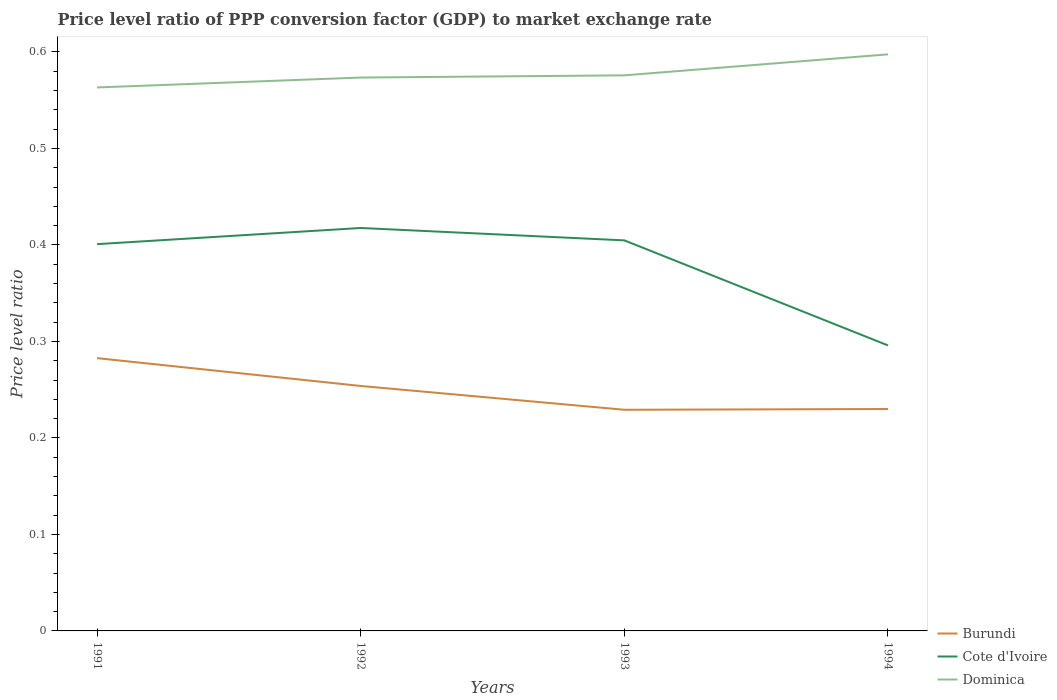Does the line corresponding to Burundi intersect with the line corresponding to Dominica?
Give a very brief answer. No. Is the number of lines equal to the number of legend labels?
Ensure brevity in your answer.  Yes. Across all years, what is the maximum price level ratio in Cote d'Ivoire?
Offer a terse response. 0.3. In which year was the price level ratio in Burundi maximum?
Your answer should be very brief. 1993. What is the total price level ratio in Burundi in the graph?
Your response must be concise. 0.05. What is the difference between the highest and the second highest price level ratio in Burundi?
Your response must be concise. 0.05. What is the difference between the highest and the lowest price level ratio in Dominica?
Give a very brief answer. 1. Is the price level ratio in Cote d'Ivoire strictly greater than the price level ratio in Dominica over the years?
Your response must be concise. Yes. How many lines are there?
Offer a very short reply. 3. What is the difference between two consecutive major ticks on the Y-axis?
Your answer should be very brief. 0.1. How are the legend labels stacked?
Your answer should be compact. Vertical. What is the title of the graph?
Offer a very short reply. Price level ratio of PPP conversion factor (GDP) to market exchange rate. What is the label or title of the X-axis?
Offer a terse response. Years. What is the label or title of the Y-axis?
Provide a short and direct response. Price level ratio. What is the Price level ratio of Burundi in 1991?
Provide a succinct answer. 0.28. What is the Price level ratio of Cote d'Ivoire in 1991?
Ensure brevity in your answer.  0.4. What is the Price level ratio in Dominica in 1991?
Ensure brevity in your answer.  0.56. What is the Price level ratio of Burundi in 1992?
Provide a short and direct response. 0.25. What is the Price level ratio in Cote d'Ivoire in 1992?
Provide a short and direct response. 0.42. What is the Price level ratio in Dominica in 1992?
Provide a short and direct response. 0.57. What is the Price level ratio in Burundi in 1993?
Keep it short and to the point. 0.23. What is the Price level ratio in Cote d'Ivoire in 1993?
Offer a very short reply. 0.4. What is the Price level ratio in Dominica in 1993?
Offer a terse response. 0.58. What is the Price level ratio in Burundi in 1994?
Keep it short and to the point. 0.23. What is the Price level ratio of Cote d'Ivoire in 1994?
Keep it short and to the point. 0.3. What is the Price level ratio in Dominica in 1994?
Your answer should be very brief. 0.6. Across all years, what is the maximum Price level ratio in Burundi?
Your answer should be very brief. 0.28. Across all years, what is the maximum Price level ratio of Cote d'Ivoire?
Make the answer very short. 0.42. Across all years, what is the maximum Price level ratio in Dominica?
Offer a terse response. 0.6. Across all years, what is the minimum Price level ratio in Burundi?
Keep it short and to the point. 0.23. Across all years, what is the minimum Price level ratio in Cote d'Ivoire?
Ensure brevity in your answer.  0.3. Across all years, what is the minimum Price level ratio in Dominica?
Provide a succinct answer. 0.56. What is the total Price level ratio in Burundi in the graph?
Provide a succinct answer. 1. What is the total Price level ratio of Cote d'Ivoire in the graph?
Provide a succinct answer. 1.52. What is the total Price level ratio of Dominica in the graph?
Offer a very short reply. 2.31. What is the difference between the Price level ratio in Burundi in 1991 and that in 1992?
Keep it short and to the point. 0.03. What is the difference between the Price level ratio in Cote d'Ivoire in 1991 and that in 1992?
Give a very brief answer. -0.02. What is the difference between the Price level ratio in Dominica in 1991 and that in 1992?
Offer a terse response. -0.01. What is the difference between the Price level ratio in Burundi in 1991 and that in 1993?
Your answer should be very brief. 0.05. What is the difference between the Price level ratio in Cote d'Ivoire in 1991 and that in 1993?
Keep it short and to the point. -0. What is the difference between the Price level ratio of Dominica in 1991 and that in 1993?
Offer a terse response. -0.01. What is the difference between the Price level ratio of Burundi in 1991 and that in 1994?
Provide a succinct answer. 0.05. What is the difference between the Price level ratio of Cote d'Ivoire in 1991 and that in 1994?
Keep it short and to the point. 0.1. What is the difference between the Price level ratio in Dominica in 1991 and that in 1994?
Offer a terse response. -0.03. What is the difference between the Price level ratio in Burundi in 1992 and that in 1993?
Provide a short and direct response. 0.02. What is the difference between the Price level ratio in Cote d'Ivoire in 1992 and that in 1993?
Ensure brevity in your answer.  0.01. What is the difference between the Price level ratio of Dominica in 1992 and that in 1993?
Your response must be concise. -0. What is the difference between the Price level ratio in Burundi in 1992 and that in 1994?
Offer a terse response. 0.02. What is the difference between the Price level ratio in Cote d'Ivoire in 1992 and that in 1994?
Provide a succinct answer. 0.12. What is the difference between the Price level ratio of Dominica in 1992 and that in 1994?
Provide a succinct answer. -0.02. What is the difference between the Price level ratio of Burundi in 1993 and that in 1994?
Offer a terse response. -0. What is the difference between the Price level ratio in Cote d'Ivoire in 1993 and that in 1994?
Offer a terse response. 0.11. What is the difference between the Price level ratio of Dominica in 1993 and that in 1994?
Ensure brevity in your answer.  -0.02. What is the difference between the Price level ratio in Burundi in 1991 and the Price level ratio in Cote d'Ivoire in 1992?
Your answer should be compact. -0.13. What is the difference between the Price level ratio of Burundi in 1991 and the Price level ratio of Dominica in 1992?
Provide a short and direct response. -0.29. What is the difference between the Price level ratio in Cote d'Ivoire in 1991 and the Price level ratio in Dominica in 1992?
Make the answer very short. -0.17. What is the difference between the Price level ratio of Burundi in 1991 and the Price level ratio of Cote d'Ivoire in 1993?
Your answer should be compact. -0.12. What is the difference between the Price level ratio in Burundi in 1991 and the Price level ratio in Dominica in 1993?
Your answer should be very brief. -0.29. What is the difference between the Price level ratio in Cote d'Ivoire in 1991 and the Price level ratio in Dominica in 1993?
Keep it short and to the point. -0.17. What is the difference between the Price level ratio of Burundi in 1991 and the Price level ratio of Cote d'Ivoire in 1994?
Your response must be concise. -0.01. What is the difference between the Price level ratio of Burundi in 1991 and the Price level ratio of Dominica in 1994?
Keep it short and to the point. -0.31. What is the difference between the Price level ratio in Cote d'Ivoire in 1991 and the Price level ratio in Dominica in 1994?
Provide a succinct answer. -0.2. What is the difference between the Price level ratio of Burundi in 1992 and the Price level ratio of Cote d'Ivoire in 1993?
Provide a short and direct response. -0.15. What is the difference between the Price level ratio in Burundi in 1992 and the Price level ratio in Dominica in 1993?
Provide a succinct answer. -0.32. What is the difference between the Price level ratio in Cote d'Ivoire in 1992 and the Price level ratio in Dominica in 1993?
Your answer should be very brief. -0.16. What is the difference between the Price level ratio of Burundi in 1992 and the Price level ratio of Cote d'Ivoire in 1994?
Your response must be concise. -0.04. What is the difference between the Price level ratio in Burundi in 1992 and the Price level ratio in Dominica in 1994?
Keep it short and to the point. -0.34. What is the difference between the Price level ratio of Cote d'Ivoire in 1992 and the Price level ratio of Dominica in 1994?
Your answer should be very brief. -0.18. What is the difference between the Price level ratio in Burundi in 1993 and the Price level ratio in Cote d'Ivoire in 1994?
Your response must be concise. -0.07. What is the difference between the Price level ratio of Burundi in 1993 and the Price level ratio of Dominica in 1994?
Your response must be concise. -0.37. What is the difference between the Price level ratio of Cote d'Ivoire in 1993 and the Price level ratio of Dominica in 1994?
Make the answer very short. -0.19. What is the average Price level ratio in Burundi per year?
Offer a terse response. 0.25. What is the average Price level ratio in Cote d'Ivoire per year?
Your response must be concise. 0.38. What is the average Price level ratio of Dominica per year?
Make the answer very short. 0.58. In the year 1991, what is the difference between the Price level ratio in Burundi and Price level ratio in Cote d'Ivoire?
Make the answer very short. -0.12. In the year 1991, what is the difference between the Price level ratio in Burundi and Price level ratio in Dominica?
Give a very brief answer. -0.28. In the year 1991, what is the difference between the Price level ratio in Cote d'Ivoire and Price level ratio in Dominica?
Offer a terse response. -0.16. In the year 1992, what is the difference between the Price level ratio in Burundi and Price level ratio in Cote d'Ivoire?
Give a very brief answer. -0.16. In the year 1992, what is the difference between the Price level ratio of Burundi and Price level ratio of Dominica?
Give a very brief answer. -0.32. In the year 1992, what is the difference between the Price level ratio in Cote d'Ivoire and Price level ratio in Dominica?
Offer a terse response. -0.16. In the year 1993, what is the difference between the Price level ratio in Burundi and Price level ratio in Cote d'Ivoire?
Your answer should be compact. -0.18. In the year 1993, what is the difference between the Price level ratio of Burundi and Price level ratio of Dominica?
Provide a short and direct response. -0.35. In the year 1993, what is the difference between the Price level ratio in Cote d'Ivoire and Price level ratio in Dominica?
Make the answer very short. -0.17. In the year 1994, what is the difference between the Price level ratio of Burundi and Price level ratio of Cote d'Ivoire?
Offer a terse response. -0.07. In the year 1994, what is the difference between the Price level ratio in Burundi and Price level ratio in Dominica?
Offer a very short reply. -0.37. In the year 1994, what is the difference between the Price level ratio of Cote d'Ivoire and Price level ratio of Dominica?
Offer a very short reply. -0.3. What is the ratio of the Price level ratio in Burundi in 1991 to that in 1992?
Your answer should be compact. 1.11. What is the ratio of the Price level ratio of Cote d'Ivoire in 1991 to that in 1992?
Provide a succinct answer. 0.96. What is the ratio of the Price level ratio in Dominica in 1991 to that in 1992?
Your response must be concise. 0.98. What is the ratio of the Price level ratio of Burundi in 1991 to that in 1993?
Your response must be concise. 1.23. What is the ratio of the Price level ratio of Cote d'Ivoire in 1991 to that in 1993?
Provide a succinct answer. 0.99. What is the ratio of the Price level ratio in Dominica in 1991 to that in 1993?
Offer a terse response. 0.98. What is the ratio of the Price level ratio of Burundi in 1991 to that in 1994?
Keep it short and to the point. 1.23. What is the ratio of the Price level ratio of Cote d'Ivoire in 1991 to that in 1994?
Give a very brief answer. 1.35. What is the ratio of the Price level ratio in Dominica in 1991 to that in 1994?
Offer a very short reply. 0.94. What is the ratio of the Price level ratio of Burundi in 1992 to that in 1993?
Provide a succinct answer. 1.11. What is the ratio of the Price level ratio in Cote d'Ivoire in 1992 to that in 1993?
Give a very brief answer. 1.03. What is the ratio of the Price level ratio in Burundi in 1992 to that in 1994?
Ensure brevity in your answer.  1.1. What is the ratio of the Price level ratio in Cote d'Ivoire in 1992 to that in 1994?
Offer a terse response. 1.41. What is the ratio of the Price level ratio in Dominica in 1992 to that in 1994?
Offer a very short reply. 0.96. What is the ratio of the Price level ratio in Cote d'Ivoire in 1993 to that in 1994?
Make the answer very short. 1.37. What is the ratio of the Price level ratio of Dominica in 1993 to that in 1994?
Provide a succinct answer. 0.96. What is the difference between the highest and the second highest Price level ratio in Burundi?
Give a very brief answer. 0.03. What is the difference between the highest and the second highest Price level ratio in Cote d'Ivoire?
Your answer should be very brief. 0.01. What is the difference between the highest and the second highest Price level ratio in Dominica?
Your response must be concise. 0.02. What is the difference between the highest and the lowest Price level ratio of Burundi?
Ensure brevity in your answer.  0.05. What is the difference between the highest and the lowest Price level ratio of Cote d'Ivoire?
Keep it short and to the point. 0.12. What is the difference between the highest and the lowest Price level ratio of Dominica?
Your response must be concise. 0.03. 